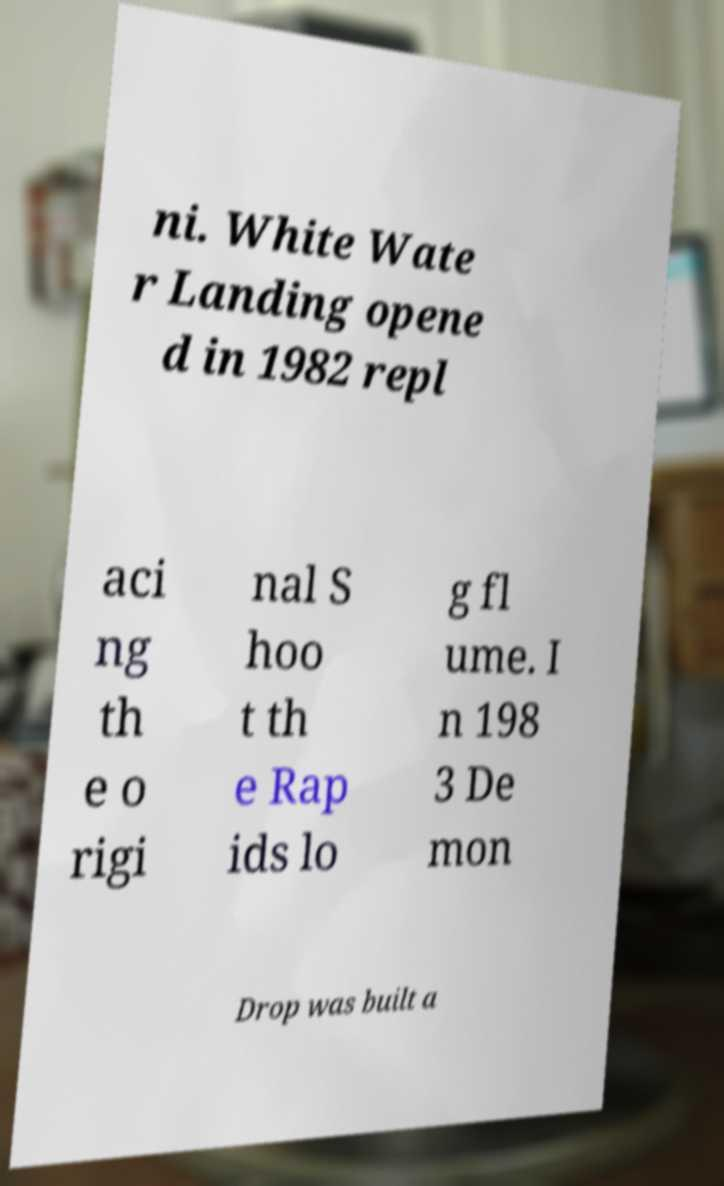Can you accurately transcribe the text from the provided image for me? ni. White Wate r Landing opene d in 1982 repl aci ng th e o rigi nal S hoo t th e Rap ids lo g fl ume. I n 198 3 De mon Drop was built a 